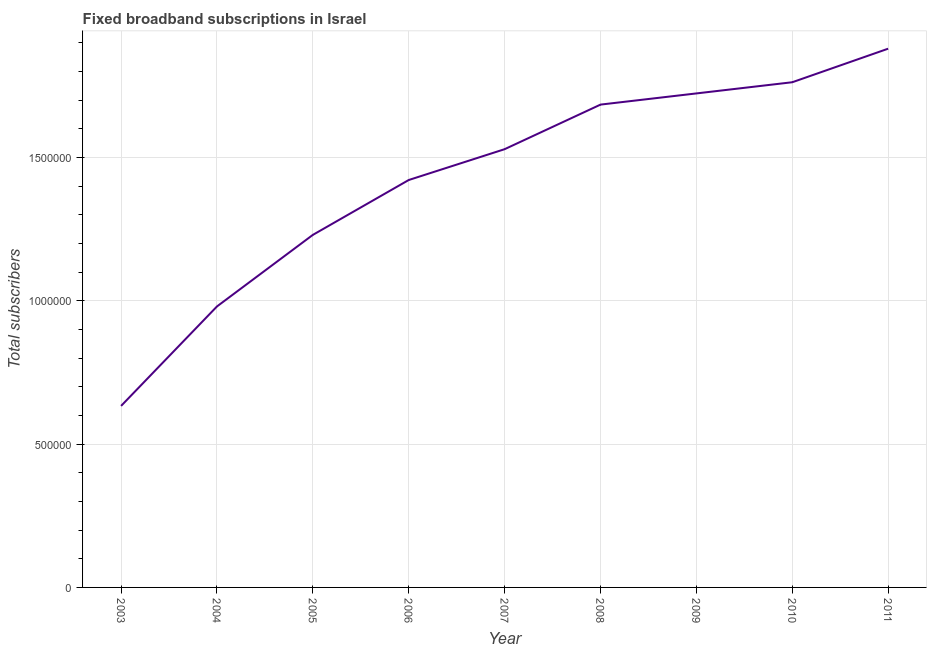What is the total number of fixed broadband subscriptions in 2005?
Your answer should be very brief. 1.23e+06. Across all years, what is the maximum total number of fixed broadband subscriptions?
Your answer should be compact. 1.88e+06. Across all years, what is the minimum total number of fixed broadband subscriptions?
Your response must be concise. 6.33e+05. What is the sum of the total number of fixed broadband subscriptions?
Keep it short and to the point. 1.28e+07. What is the difference between the total number of fixed broadband subscriptions in 2009 and 2010?
Keep it short and to the point. -3.90e+04. What is the average total number of fixed broadband subscriptions per year?
Provide a succinct answer. 1.43e+06. What is the median total number of fixed broadband subscriptions?
Ensure brevity in your answer.  1.53e+06. In how many years, is the total number of fixed broadband subscriptions greater than 900000 ?
Ensure brevity in your answer.  8. What is the ratio of the total number of fixed broadband subscriptions in 2006 to that in 2010?
Give a very brief answer. 0.81. What is the difference between the highest and the second highest total number of fixed broadband subscriptions?
Your response must be concise. 1.17e+05. Is the sum of the total number of fixed broadband subscriptions in 2007 and 2010 greater than the maximum total number of fixed broadband subscriptions across all years?
Ensure brevity in your answer.  Yes. What is the difference between the highest and the lowest total number of fixed broadband subscriptions?
Offer a terse response. 1.25e+06. In how many years, is the total number of fixed broadband subscriptions greater than the average total number of fixed broadband subscriptions taken over all years?
Provide a short and direct response. 5. How many lines are there?
Offer a terse response. 1. What is the difference between two consecutive major ticks on the Y-axis?
Make the answer very short. 5.00e+05. What is the title of the graph?
Provide a succinct answer. Fixed broadband subscriptions in Israel. What is the label or title of the Y-axis?
Ensure brevity in your answer.  Total subscribers. What is the Total subscribers in 2003?
Your answer should be compact. 6.33e+05. What is the Total subscribers of 2004?
Your response must be concise. 9.80e+05. What is the Total subscribers of 2005?
Ensure brevity in your answer.  1.23e+06. What is the Total subscribers in 2006?
Give a very brief answer. 1.42e+06. What is the Total subscribers of 2007?
Your response must be concise. 1.53e+06. What is the Total subscribers of 2008?
Provide a short and direct response. 1.68e+06. What is the Total subscribers in 2009?
Offer a very short reply. 1.72e+06. What is the Total subscribers in 2010?
Your answer should be compact. 1.76e+06. What is the Total subscribers of 2011?
Provide a succinct answer. 1.88e+06. What is the difference between the Total subscribers in 2003 and 2004?
Provide a short and direct response. -3.47e+05. What is the difference between the Total subscribers in 2003 and 2005?
Ensure brevity in your answer.  -5.97e+05. What is the difference between the Total subscribers in 2003 and 2006?
Ensure brevity in your answer.  -7.88e+05. What is the difference between the Total subscribers in 2003 and 2007?
Give a very brief answer. -8.95e+05. What is the difference between the Total subscribers in 2003 and 2008?
Ensure brevity in your answer.  -1.05e+06. What is the difference between the Total subscribers in 2003 and 2009?
Make the answer very short. -1.09e+06. What is the difference between the Total subscribers in 2003 and 2010?
Keep it short and to the point. -1.13e+06. What is the difference between the Total subscribers in 2003 and 2011?
Offer a terse response. -1.25e+06. What is the difference between the Total subscribers in 2004 and 2005?
Keep it short and to the point. -2.50e+05. What is the difference between the Total subscribers in 2004 and 2006?
Offer a terse response. -4.41e+05. What is the difference between the Total subscribers in 2004 and 2007?
Your response must be concise. -5.48e+05. What is the difference between the Total subscribers in 2004 and 2008?
Ensure brevity in your answer.  -7.04e+05. What is the difference between the Total subscribers in 2004 and 2009?
Ensure brevity in your answer.  -7.43e+05. What is the difference between the Total subscribers in 2004 and 2010?
Your answer should be compact. -7.82e+05. What is the difference between the Total subscribers in 2004 and 2011?
Your response must be concise. -8.99e+05. What is the difference between the Total subscribers in 2005 and 2006?
Give a very brief answer. -1.91e+05. What is the difference between the Total subscribers in 2005 and 2007?
Your answer should be compact. -2.99e+05. What is the difference between the Total subscribers in 2005 and 2008?
Your answer should be very brief. -4.54e+05. What is the difference between the Total subscribers in 2005 and 2009?
Ensure brevity in your answer.  -4.93e+05. What is the difference between the Total subscribers in 2005 and 2010?
Your answer should be very brief. -5.32e+05. What is the difference between the Total subscribers in 2005 and 2011?
Keep it short and to the point. -6.49e+05. What is the difference between the Total subscribers in 2006 and 2007?
Give a very brief answer. -1.08e+05. What is the difference between the Total subscribers in 2006 and 2008?
Keep it short and to the point. -2.63e+05. What is the difference between the Total subscribers in 2006 and 2009?
Offer a very short reply. -3.02e+05. What is the difference between the Total subscribers in 2006 and 2010?
Your answer should be very brief. -3.41e+05. What is the difference between the Total subscribers in 2006 and 2011?
Your answer should be compact. -4.58e+05. What is the difference between the Total subscribers in 2007 and 2008?
Offer a terse response. -1.56e+05. What is the difference between the Total subscribers in 2007 and 2009?
Provide a succinct answer. -1.94e+05. What is the difference between the Total subscribers in 2007 and 2010?
Provide a succinct answer. -2.34e+05. What is the difference between the Total subscribers in 2007 and 2011?
Give a very brief answer. -3.51e+05. What is the difference between the Total subscribers in 2008 and 2009?
Your response must be concise. -3.90e+04. What is the difference between the Total subscribers in 2008 and 2010?
Give a very brief answer. -7.80e+04. What is the difference between the Total subscribers in 2008 and 2011?
Your response must be concise. -1.95e+05. What is the difference between the Total subscribers in 2009 and 2010?
Ensure brevity in your answer.  -3.90e+04. What is the difference between the Total subscribers in 2009 and 2011?
Give a very brief answer. -1.56e+05. What is the difference between the Total subscribers in 2010 and 2011?
Offer a terse response. -1.17e+05. What is the ratio of the Total subscribers in 2003 to that in 2004?
Your answer should be very brief. 0.65. What is the ratio of the Total subscribers in 2003 to that in 2005?
Provide a short and direct response. 0.52. What is the ratio of the Total subscribers in 2003 to that in 2006?
Your answer should be compact. 0.45. What is the ratio of the Total subscribers in 2003 to that in 2007?
Make the answer very short. 0.41. What is the ratio of the Total subscribers in 2003 to that in 2008?
Keep it short and to the point. 0.38. What is the ratio of the Total subscribers in 2003 to that in 2009?
Keep it short and to the point. 0.37. What is the ratio of the Total subscribers in 2003 to that in 2010?
Your response must be concise. 0.36. What is the ratio of the Total subscribers in 2003 to that in 2011?
Provide a succinct answer. 0.34. What is the ratio of the Total subscribers in 2004 to that in 2005?
Your answer should be compact. 0.8. What is the ratio of the Total subscribers in 2004 to that in 2006?
Make the answer very short. 0.69. What is the ratio of the Total subscribers in 2004 to that in 2007?
Keep it short and to the point. 0.64. What is the ratio of the Total subscribers in 2004 to that in 2008?
Give a very brief answer. 0.58. What is the ratio of the Total subscribers in 2004 to that in 2009?
Make the answer very short. 0.57. What is the ratio of the Total subscribers in 2004 to that in 2010?
Offer a very short reply. 0.56. What is the ratio of the Total subscribers in 2004 to that in 2011?
Keep it short and to the point. 0.52. What is the ratio of the Total subscribers in 2005 to that in 2006?
Provide a short and direct response. 0.86. What is the ratio of the Total subscribers in 2005 to that in 2007?
Offer a terse response. 0.8. What is the ratio of the Total subscribers in 2005 to that in 2008?
Provide a short and direct response. 0.73. What is the ratio of the Total subscribers in 2005 to that in 2009?
Ensure brevity in your answer.  0.71. What is the ratio of the Total subscribers in 2005 to that in 2010?
Offer a terse response. 0.7. What is the ratio of the Total subscribers in 2005 to that in 2011?
Keep it short and to the point. 0.65. What is the ratio of the Total subscribers in 2006 to that in 2008?
Offer a very short reply. 0.84. What is the ratio of the Total subscribers in 2006 to that in 2009?
Your answer should be very brief. 0.82. What is the ratio of the Total subscribers in 2006 to that in 2010?
Keep it short and to the point. 0.81. What is the ratio of the Total subscribers in 2006 to that in 2011?
Offer a very short reply. 0.76. What is the ratio of the Total subscribers in 2007 to that in 2008?
Your response must be concise. 0.91. What is the ratio of the Total subscribers in 2007 to that in 2009?
Offer a terse response. 0.89. What is the ratio of the Total subscribers in 2007 to that in 2010?
Offer a terse response. 0.87. What is the ratio of the Total subscribers in 2007 to that in 2011?
Provide a succinct answer. 0.81. What is the ratio of the Total subscribers in 2008 to that in 2009?
Keep it short and to the point. 0.98. What is the ratio of the Total subscribers in 2008 to that in 2010?
Keep it short and to the point. 0.96. What is the ratio of the Total subscribers in 2008 to that in 2011?
Provide a succinct answer. 0.9. What is the ratio of the Total subscribers in 2009 to that in 2011?
Your response must be concise. 0.92. What is the ratio of the Total subscribers in 2010 to that in 2011?
Your answer should be compact. 0.94. 